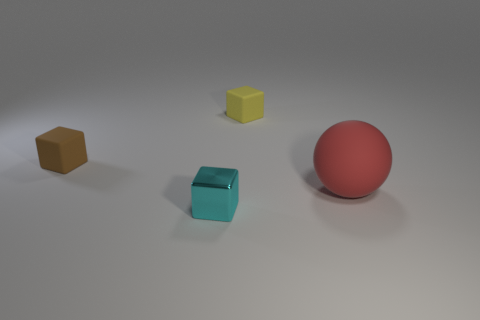Add 1 large yellow blocks. How many objects exist? 5 Subtract all spheres. How many objects are left? 3 Add 1 yellow matte cubes. How many yellow matte cubes are left? 2 Add 4 tiny cyan shiny blocks. How many tiny cyan shiny blocks exist? 5 Subtract 0 brown spheres. How many objects are left? 4 Subtract all big blue metal cylinders. Subtract all small things. How many objects are left? 1 